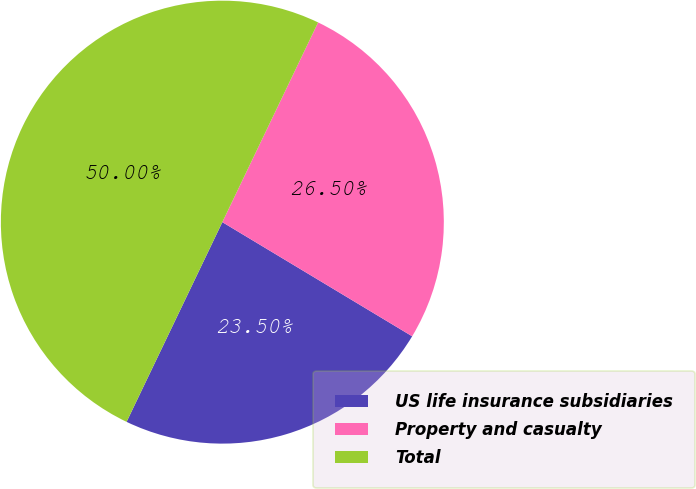<chart> <loc_0><loc_0><loc_500><loc_500><pie_chart><fcel>US life insurance subsidiaries<fcel>Property and casualty<fcel>Total<nl><fcel>23.5%<fcel>26.5%<fcel>50.0%<nl></chart> 